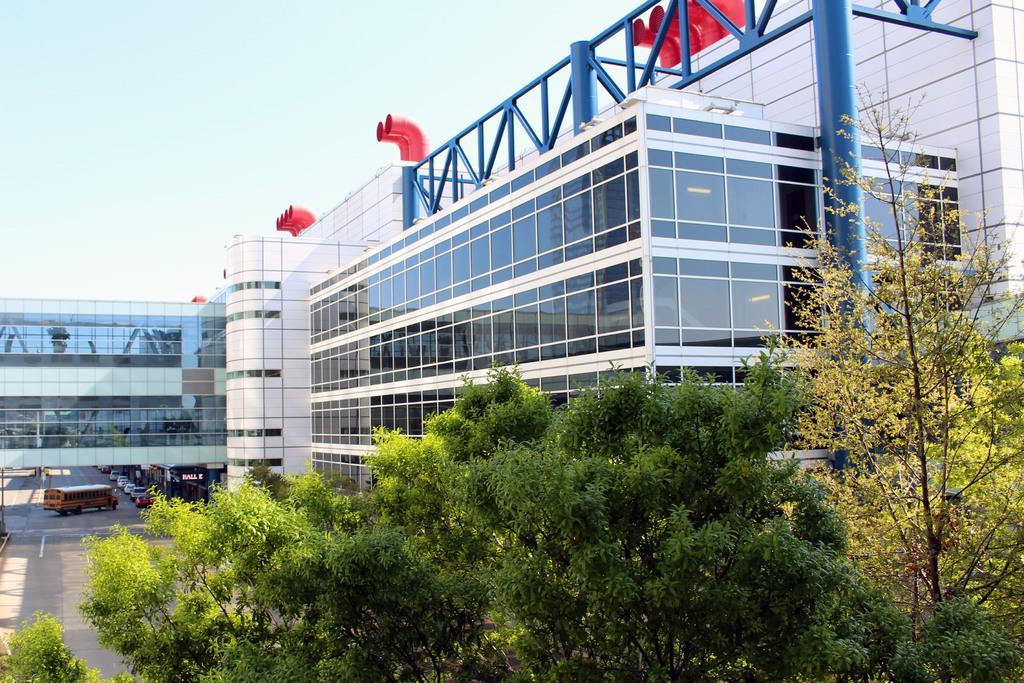Could you give a brief overview of what you see in this image? In this picture there is a building. On the left side of the image there are vehicles on the road. In the foreground there are tree. At the top there is sky and there are pipes on the top of the building and there are lights inside the building. At the bottom there is a road. 